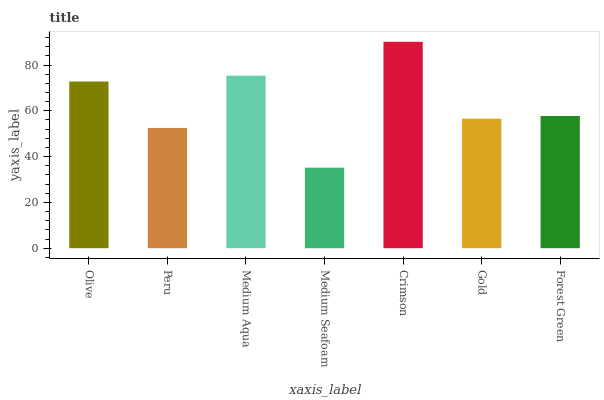Is Peru the minimum?
Answer yes or no. No. Is Peru the maximum?
Answer yes or no. No. Is Olive greater than Peru?
Answer yes or no. Yes. Is Peru less than Olive?
Answer yes or no. Yes. Is Peru greater than Olive?
Answer yes or no. No. Is Olive less than Peru?
Answer yes or no. No. Is Forest Green the high median?
Answer yes or no. Yes. Is Forest Green the low median?
Answer yes or no. Yes. Is Medium Seafoam the high median?
Answer yes or no. No. Is Peru the low median?
Answer yes or no. No. 